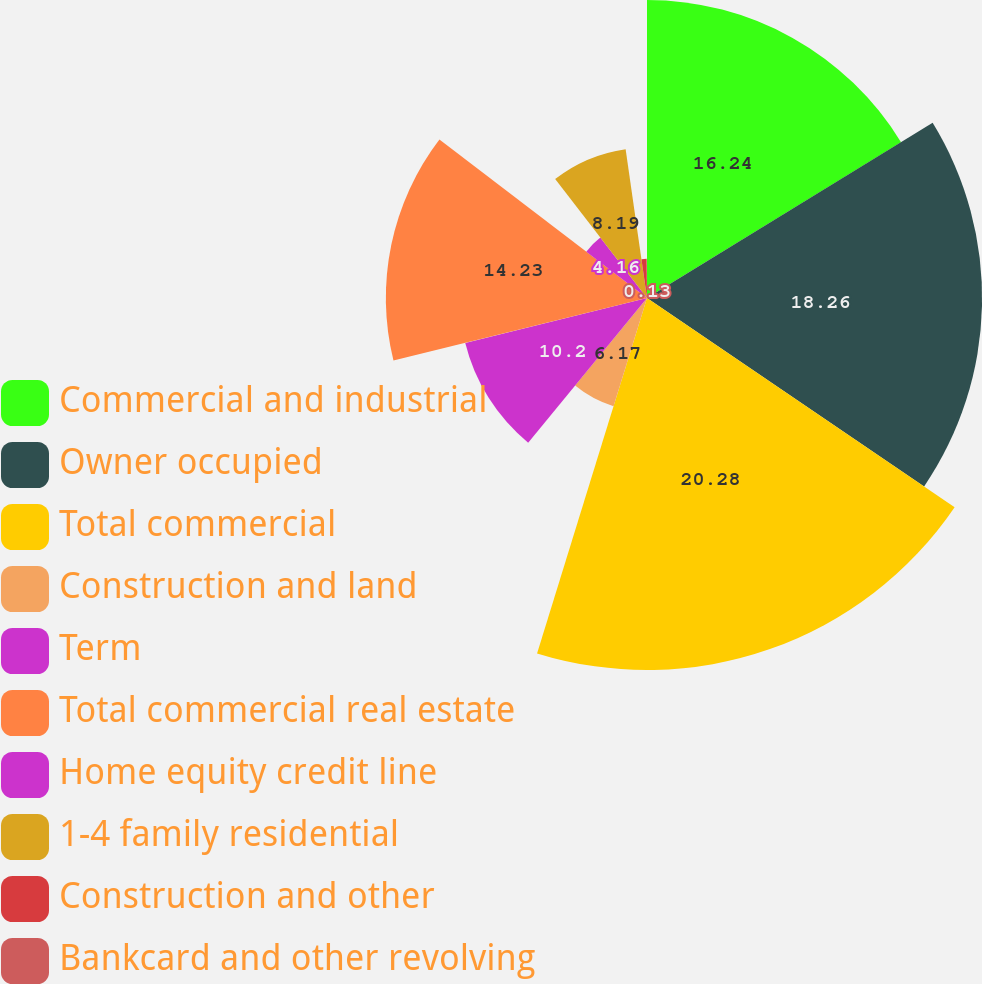<chart> <loc_0><loc_0><loc_500><loc_500><pie_chart><fcel>Commercial and industrial<fcel>Owner occupied<fcel>Total commercial<fcel>Construction and land<fcel>Term<fcel>Total commercial real estate<fcel>Home equity credit line<fcel>1-4 family residential<fcel>Construction and other<fcel>Bankcard and other revolving<nl><fcel>16.24%<fcel>18.26%<fcel>20.27%<fcel>6.17%<fcel>10.2%<fcel>14.23%<fcel>4.16%<fcel>8.19%<fcel>2.14%<fcel>0.13%<nl></chart> 